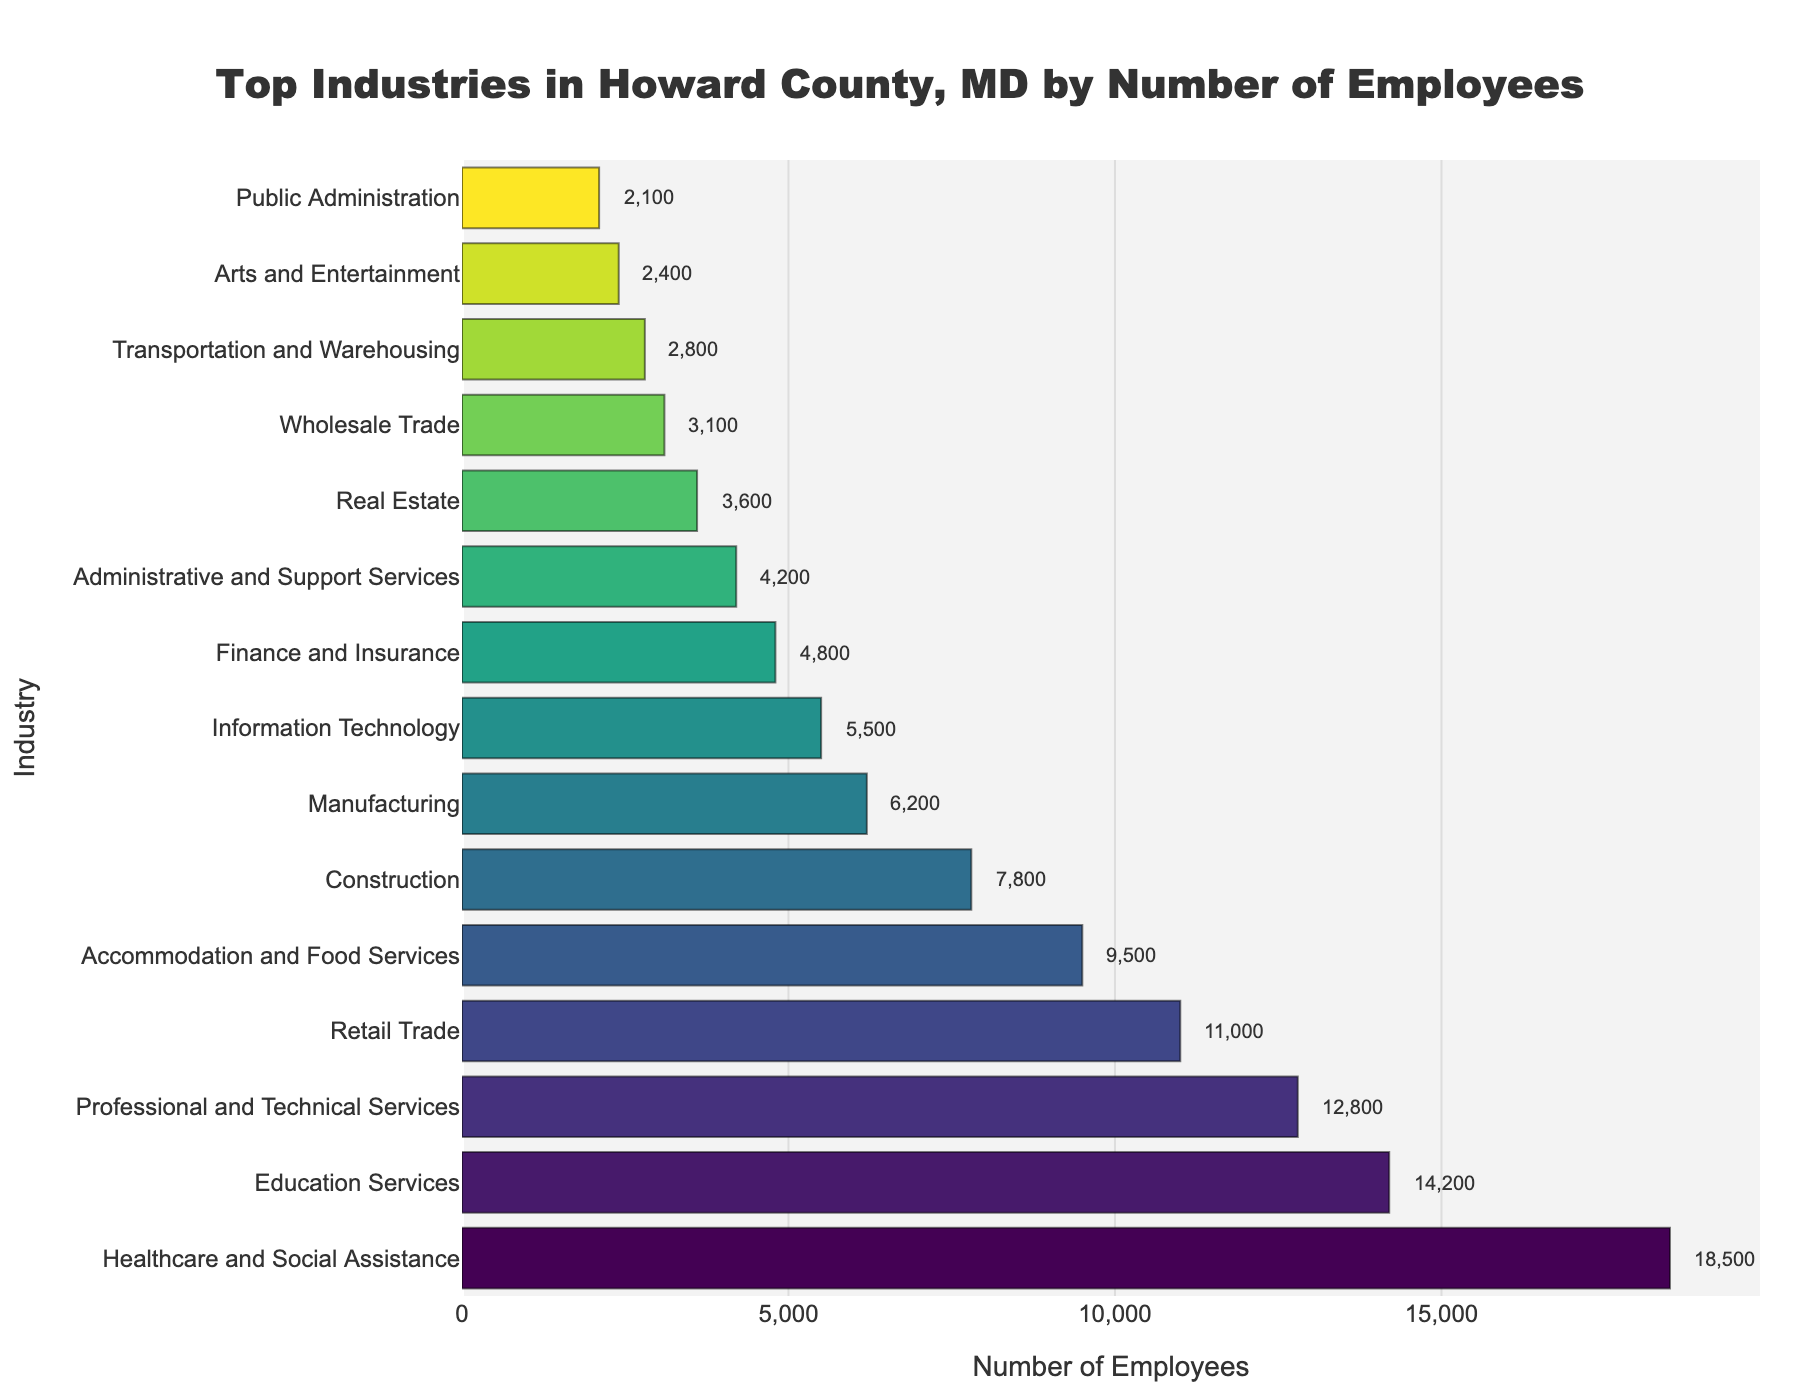What industry employs the most people? The bar chart shows that the Healthcare and Social Assistance industry has the longest bar, indicating the highest number of employees, at 18,500.
Answer: Healthcare and Social Assistance Which two industries have the closest number of employees? Retail Trade and Accommodation and Food Services have 11,000 and 9,500 employees respectively. The difference between the two is 1,500, which is smaller than the differences between any other adjacent industries in the chart.
Answer: Retail Trade and Accommodation and Food Services How many people are employed in total by the top three industries? The top three industries are Healthcare and Social Assistance (18,500), Education Services (14,200), and Professional and Technical Services (12,800). Their total is 18,500 + 14,200 + 12,800 = 45,500.
Answer: 45,500 Which industry employs more people: Construction or Information Technology? The chart shows that Construction employs 7,800 people, while Information Technology employs 5,500 people. Construction employs more people.
Answer: Construction What is the average number of employees across all listed industries? First, sum all the employees numbers: 18,500 + 14,200 + 12,800 + 11,000 + 9,500 + 7,800 + 6,200 + 5,500 + 4,800 + 4,200 + 3,600 + 3,100 + 2,800 + 2,400 + 2,100 = 108,500. Then divide by 15 industries: 108,500 / 15 = 7,233.33.
Answer: 7,233.33 How does the number of employees in Manufacturing compare to Administrative and Support Services? Manufacturing has 6,200 employees while Administrative and Support Services have 4,200 employees. Manufacturing has 2,000 more employees.
Answer: Manufacturing has 2,000 more employees Which industry has the shortest bar in the chart? The bar chart indicates that Public Administration has the shortest bar with 2,100 employees.
Answer: Public Administration What is the total number of employees in industries with fewer than 5,000 employees? The industries with fewer than 5,000 employees are Finance and Insurance (4,800), Administrative and Support Services (4,200), Real Estate (3,600), Wholesale Trade (3,100), Transportation and Warehousing (2,800), Arts and Entertainment (2,400), and Public Administration (2,100). Their total is: 4,800 + 4,200 + 3,600 + 3,100 + 2,800 + 2,400 + 2,100 = 23,000.
Answer: 23,000 If Professional and Technical Services grew by 10%, how many employees would it have? Professional and Technical Services currently have 12,800 employees. If it grew by 10%, the increase would be 12,800 * 0.10 = 1,280. Adding this to the current number gives 12,800 + 1,280 = 14,080.
Answer: 14,080 